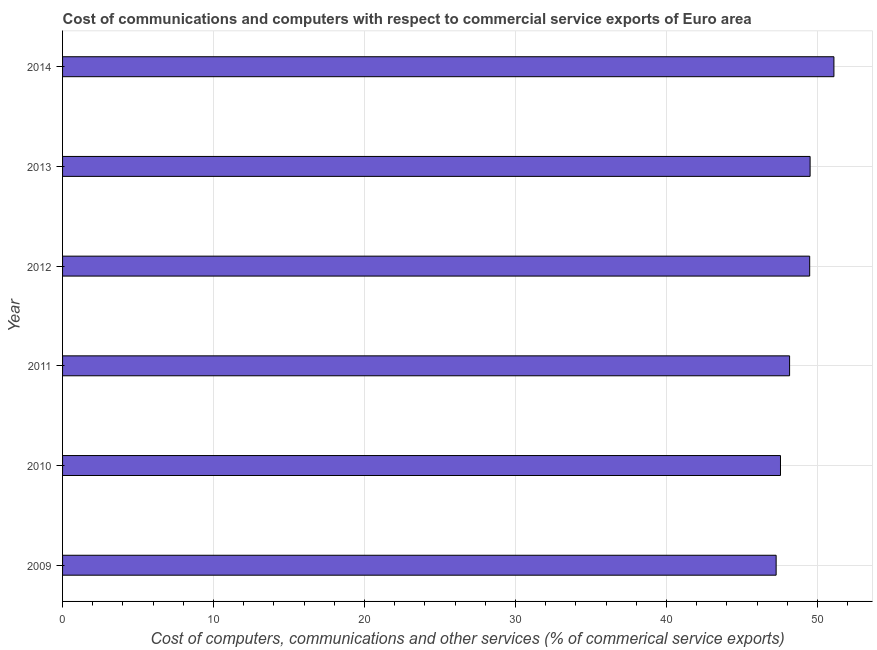Does the graph contain any zero values?
Your answer should be very brief. No. What is the title of the graph?
Your answer should be very brief. Cost of communications and computers with respect to commercial service exports of Euro area. What is the label or title of the X-axis?
Offer a very short reply. Cost of computers, communications and other services (% of commerical service exports). What is the label or title of the Y-axis?
Make the answer very short. Year. What is the  computer and other services in 2009?
Offer a very short reply. 47.26. Across all years, what is the maximum cost of communications?
Provide a short and direct response. 51.09. Across all years, what is the minimum cost of communications?
Your answer should be very brief. 47.26. In which year was the  computer and other services minimum?
Ensure brevity in your answer.  2009. What is the sum of the cost of communications?
Your answer should be compact. 293.04. What is the difference between the  computer and other services in 2013 and 2014?
Give a very brief answer. -1.58. What is the average  computer and other services per year?
Your answer should be very brief. 48.84. What is the median  computer and other services?
Your answer should be very brief. 48.82. What is the ratio of the cost of communications in 2011 to that in 2013?
Offer a terse response. 0.97. Is the difference between the cost of communications in 2009 and 2012 greater than the difference between any two years?
Make the answer very short. No. What is the difference between the highest and the second highest  computer and other services?
Your answer should be very brief. 1.58. What is the difference between the highest and the lowest cost of communications?
Give a very brief answer. 3.83. In how many years, is the cost of communications greater than the average cost of communications taken over all years?
Make the answer very short. 3. How many bars are there?
Your answer should be very brief. 6. Are the values on the major ticks of X-axis written in scientific E-notation?
Keep it short and to the point. No. What is the Cost of computers, communications and other services (% of commerical service exports) of 2009?
Keep it short and to the point. 47.26. What is the Cost of computers, communications and other services (% of commerical service exports) in 2010?
Provide a succinct answer. 47.55. What is the Cost of computers, communications and other services (% of commerical service exports) of 2011?
Ensure brevity in your answer.  48.15. What is the Cost of computers, communications and other services (% of commerical service exports) in 2012?
Ensure brevity in your answer.  49.48. What is the Cost of computers, communications and other services (% of commerical service exports) of 2013?
Keep it short and to the point. 49.51. What is the Cost of computers, communications and other services (% of commerical service exports) of 2014?
Give a very brief answer. 51.09. What is the difference between the Cost of computers, communications and other services (% of commerical service exports) in 2009 and 2010?
Ensure brevity in your answer.  -0.29. What is the difference between the Cost of computers, communications and other services (% of commerical service exports) in 2009 and 2011?
Provide a short and direct response. -0.89. What is the difference between the Cost of computers, communications and other services (% of commerical service exports) in 2009 and 2012?
Provide a succinct answer. -2.22. What is the difference between the Cost of computers, communications and other services (% of commerical service exports) in 2009 and 2013?
Ensure brevity in your answer.  -2.25. What is the difference between the Cost of computers, communications and other services (% of commerical service exports) in 2009 and 2014?
Provide a short and direct response. -3.83. What is the difference between the Cost of computers, communications and other services (% of commerical service exports) in 2010 and 2011?
Offer a very short reply. -0.6. What is the difference between the Cost of computers, communications and other services (% of commerical service exports) in 2010 and 2012?
Keep it short and to the point. -1.93. What is the difference between the Cost of computers, communications and other services (% of commerical service exports) in 2010 and 2013?
Offer a very short reply. -1.96. What is the difference between the Cost of computers, communications and other services (% of commerical service exports) in 2010 and 2014?
Ensure brevity in your answer.  -3.54. What is the difference between the Cost of computers, communications and other services (% of commerical service exports) in 2011 and 2012?
Keep it short and to the point. -1.33. What is the difference between the Cost of computers, communications and other services (% of commerical service exports) in 2011 and 2013?
Provide a short and direct response. -1.36. What is the difference between the Cost of computers, communications and other services (% of commerical service exports) in 2011 and 2014?
Your answer should be compact. -2.94. What is the difference between the Cost of computers, communications and other services (% of commerical service exports) in 2012 and 2013?
Your answer should be compact. -0.03. What is the difference between the Cost of computers, communications and other services (% of commerical service exports) in 2012 and 2014?
Keep it short and to the point. -1.61. What is the difference between the Cost of computers, communications and other services (% of commerical service exports) in 2013 and 2014?
Offer a terse response. -1.58. What is the ratio of the Cost of computers, communications and other services (% of commerical service exports) in 2009 to that in 2011?
Offer a terse response. 0.98. What is the ratio of the Cost of computers, communications and other services (% of commerical service exports) in 2009 to that in 2012?
Provide a succinct answer. 0.95. What is the ratio of the Cost of computers, communications and other services (% of commerical service exports) in 2009 to that in 2013?
Make the answer very short. 0.95. What is the ratio of the Cost of computers, communications and other services (% of commerical service exports) in 2009 to that in 2014?
Give a very brief answer. 0.93. What is the ratio of the Cost of computers, communications and other services (% of commerical service exports) in 2010 to that in 2013?
Your answer should be very brief. 0.96. What is the ratio of the Cost of computers, communications and other services (% of commerical service exports) in 2011 to that in 2013?
Keep it short and to the point. 0.97. What is the ratio of the Cost of computers, communications and other services (% of commerical service exports) in 2011 to that in 2014?
Your answer should be compact. 0.94. What is the ratio of the Cost of computers, communications and other services (% of commerical service exports) in 2012 to that in 2013?
Your answer should be compact. 1. What is the ratio of the Cost of computers, communications and other services (% of commerical service exports) in 2012 to that in 2014?
Your response must be concise. 0.97. What is the ratio of the Cost of computers, communications and other services (% of commerical service exports) in 2013 to that in 2014?
Your answer should be very brief. 0.97. 